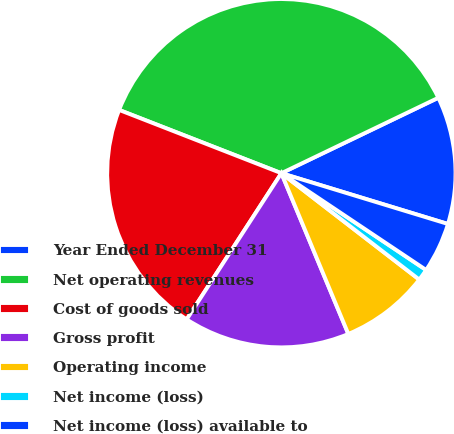Convert chart. <chart><loc_0><loc_0><loc_500><loc_500><pie_chart><fcel>Year Ended December 31<fcel>Net operating revenues<fcel>Cost of goods sold<fcel>Gross profit<fcel>Operating income<fcel>Net income (loss)<fcel>Net income (loss) available to<nl><fcel>11.84%<fcel>36.95%<fcel>21.77%<fcel>15.43%<fcel>8.26%<fcel>1.08%<fcel>4.67%<nl></chart> 